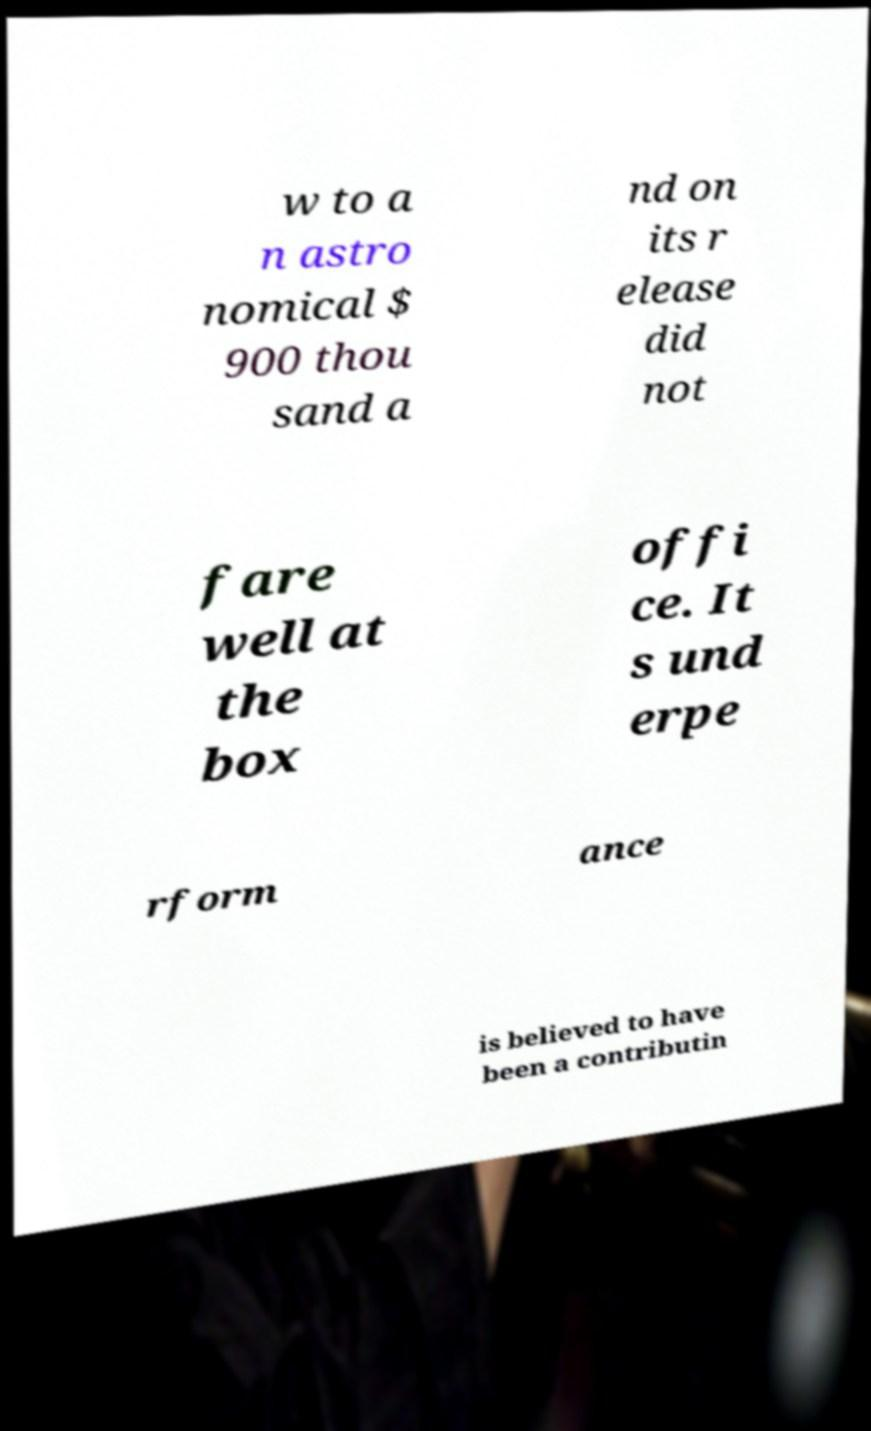Could you extract and type out the text from this image? w to a n astro nomical $ 900 thou sand a nd on its r elease did not fare well at the box offi ce. It s und erpe rform ance is believed to have been a contributin 